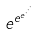<formula> <loc_0><loc_0><loc_500><loc_500>e ^ { e ^ { e ^ { \cdot ^ { \cdot ^ { \cdot } } } } }</formula> 